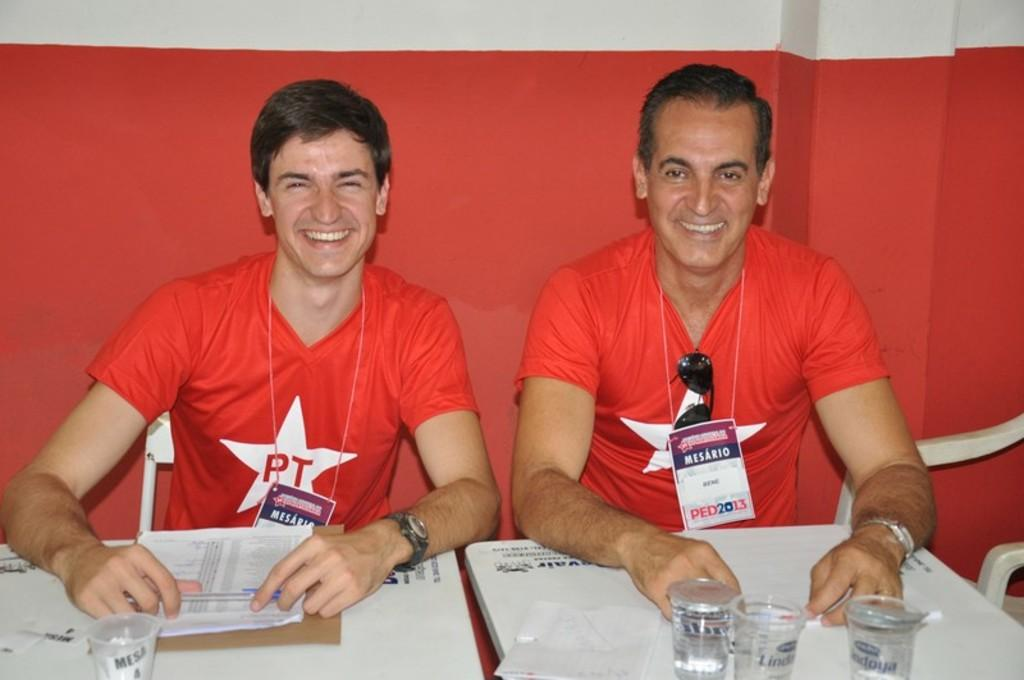<image>
Share a concise interpretation of the image provided. Two white males sitting next to each other in read shirts with PT in a star on them. 